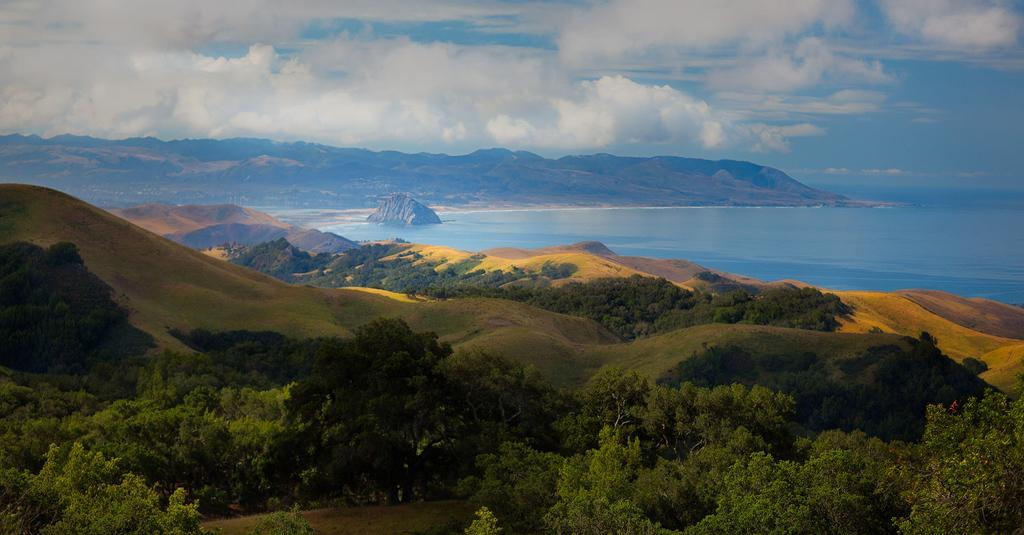What can be seen in the sky in the image? The sky with clouds is visible in the image. What type of landscape feature is present in the image? There are hills in the image. What body of water is visible in the image? There is water visible in the image. What is the surface on which the hills and water are located? The ground is present in the image. What type of vegetation can be seen in the image? Trees are present in the image. How many girls are measuring the humor in the image? There are no girls or humor present in the image. 